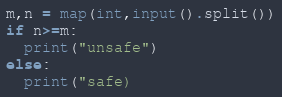<code> <loc_0><loc_0><loc_500><loc_500><_Python_>m,n = map(int,input().split())
if n>=m:
  print("unsafe")
else:
  print("safe)</code> 